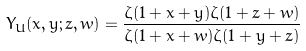Convert formula to latex. <formula><loc_0><loc_0><loc_500><loc_500>Y _ { U } ( x , y ; z , w ) = \frac { \zeta ( 1 + x + y ) \zeta ( 1 + z + w ) } { \zeta ( 1 + x + w ) \zeta ( 1 + y + z ) }</formula> 